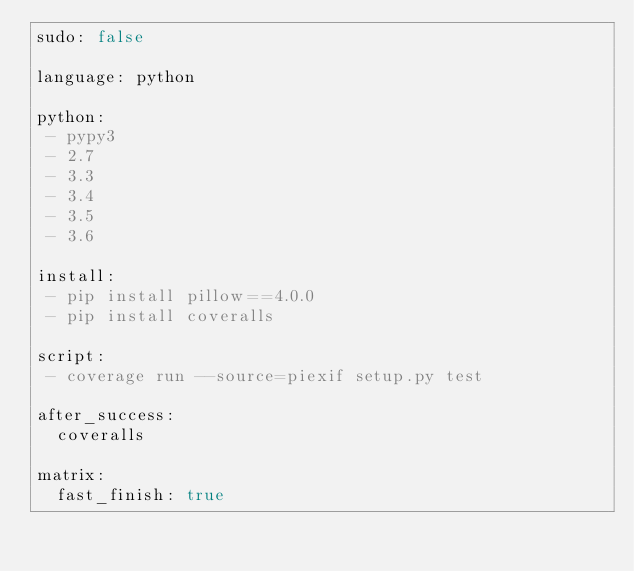<code> <loc_0><loc_0><loc_500><loc_500><_YAML_>sudo: false

language: python

python:
 - pypy3
 - 2.7
 - 3.3
 - 3.4
 - 3.5
 - 3.6

install:
 - pip install pillow==4.0.0
 - pip install coveralls

script:
 - coverage run --source=piexif setup.py test

after_success:
  coveralls

matrix:
  fast_finish: true
</code> 